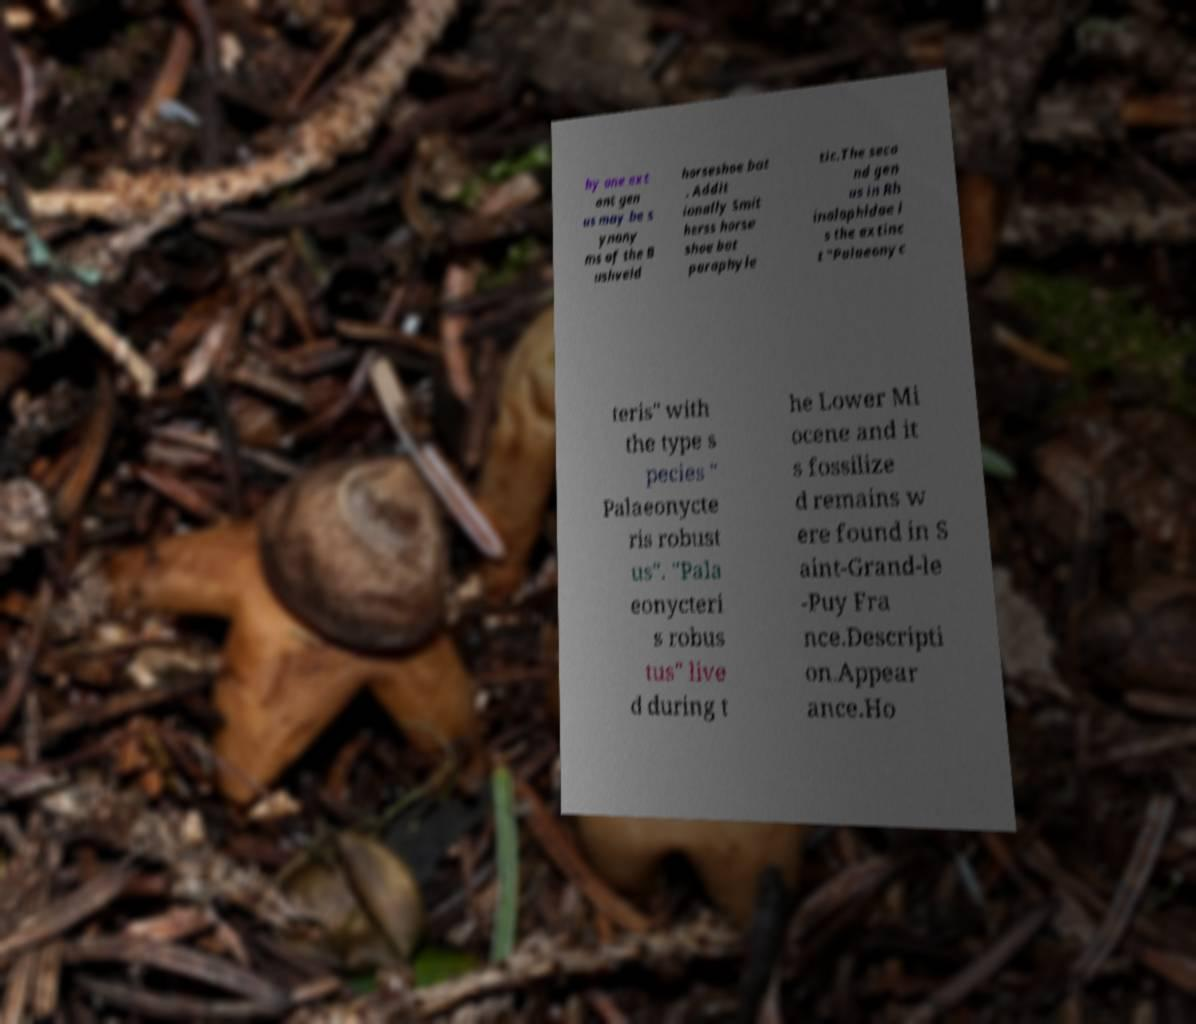There's text embedded in this image that I need extracted. Can you transcribe it verbatim? by one ext ant gen us may be s ynony ms of the B ushveld horseshoe bat . Addit ionally Smit herss horse shoe bat paraphyle tic.The seco nd gen us in Rh inolophidae i s the extinc t "Palaeonyc teris" with the type s pecies " Palaeonycte ris robust us". "Pala eonycteri s robus tus" live d during t he Lower Mi ocene and it s fossilize d remains w ere found in S aint-Grand-le -Puy Fra nce.Descripti on.Appear ance.Ho 